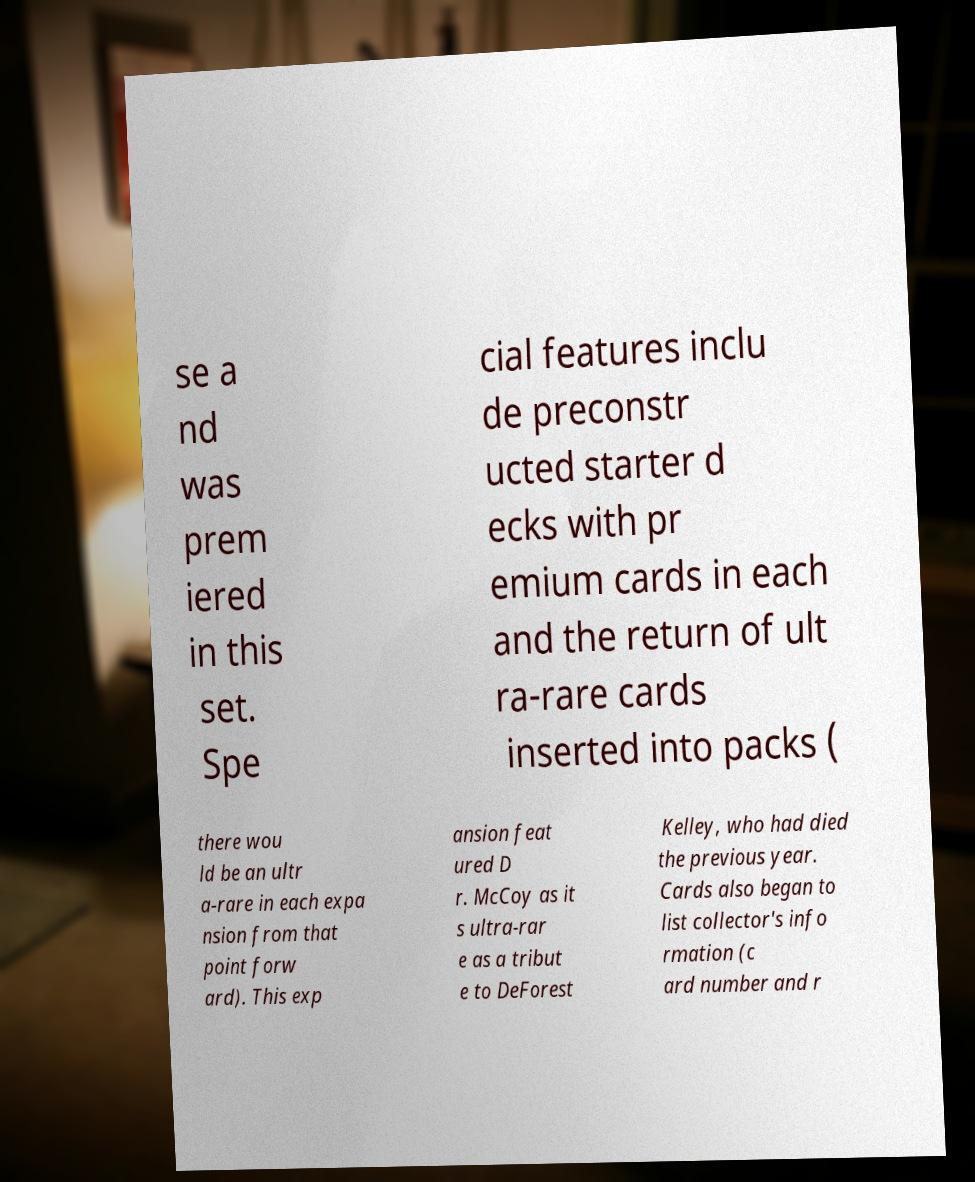There's text embedded in this image that I need extracted. Can you transcribe it verbatim? se a nd was prem iered in this set. Spe cial features inclu de preconstr ucted starter d ecks with pr emium cards in each and the return of ult ra-rare cards inserted into packs ( there wou ld be an ultr a-rare in each expa nsion from that point forw ard). This exp ansion feat ured D r. McCoy as it s ultra-rar e as a tribut e to DeForest Kelley, who had died the previous year. Cards also began to list collector's info rmation (c ard number and r 